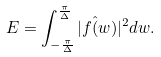Convert formula to latex. <formula><loc_0><loc_0><loc_500><loc_500>E = \int _ { - \frac { \pi } { \Delta } } ^ { \frac { \pi } { \Delta } } | f \hat { ( } w ) | ^ { 2 } d w .</formula> 